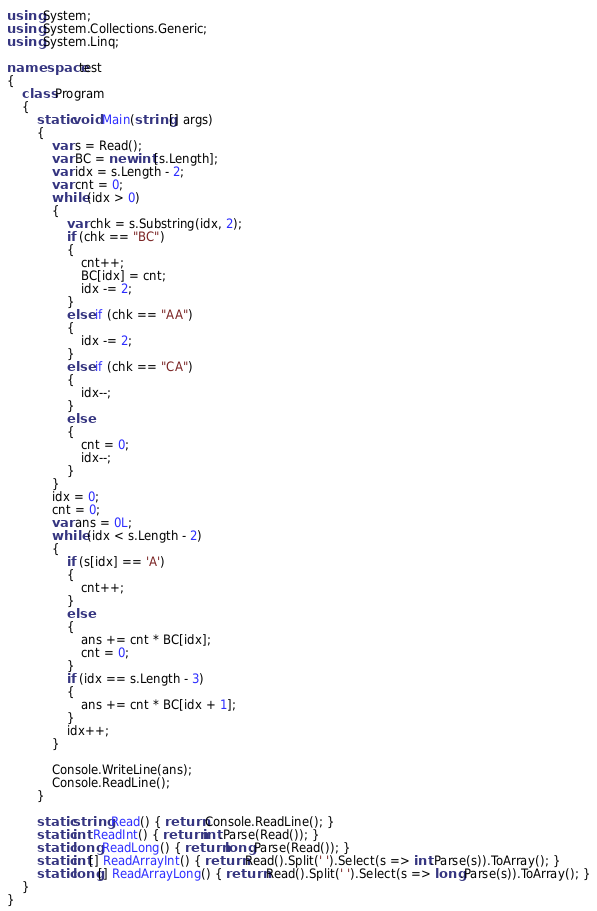Convert code to text. <code><loc_0><loc_0><loc_500><loc_500><_C#_>using System;
using System.Collections.Generic;
using System.Linq;

namespace test
{
    class Program
    {
        static void Main(string[] args)
        {
            var s = Read();
            var BC = new int[s.Length];
            var idx = s.Length - 2;
            var cnt = 0;
            while (idx > 0)
            {
                var chk = s.Substring(idx, 2);
                if (chk == "BC")
                {
                    cnt++;
                    BC[idx] = cnt;
                    idx -= 2;
                }
                else if (chk == "AA")
                {
                    idx -= 2;
                }
                else if (chk == "CA")
                {
                    idx--;
                }
                else
                {
                    cnt = 0;
                    idx--;
                }
            }
            idx = 0;
            cnt = 0;
            var ans = 0L;
            while (idx < s.Length - 2)
            {
                if (s[idx] == 'A')
                {
                    cnt++;
                }
                else
                {
                    ans += cnt * BC[idx];
                    cnt = 0;
                }
                if (idx == s.Length - 3)
                {
                    ans += cnt * BC[idx + 1];
                }
                idx++;
            }

            Console.WriteLine(ans);
            Console.ReadLine();
        }

        static string Read() { return Console.ReadLine(); }
        static int ReadInt() { return int.Parse(Read()); }
        static long ReadLong() { return long.Parse(Read()); }
        static int[] ReadArrayInt() { return Read().Split(' ').Select(s => int.Parse(s)).ToArray(); }
        static long[] ReadArrayLong() { return Read().Split(' ').Select(s => long.Parse(s)).ToArray(); }
    }
}</code> 